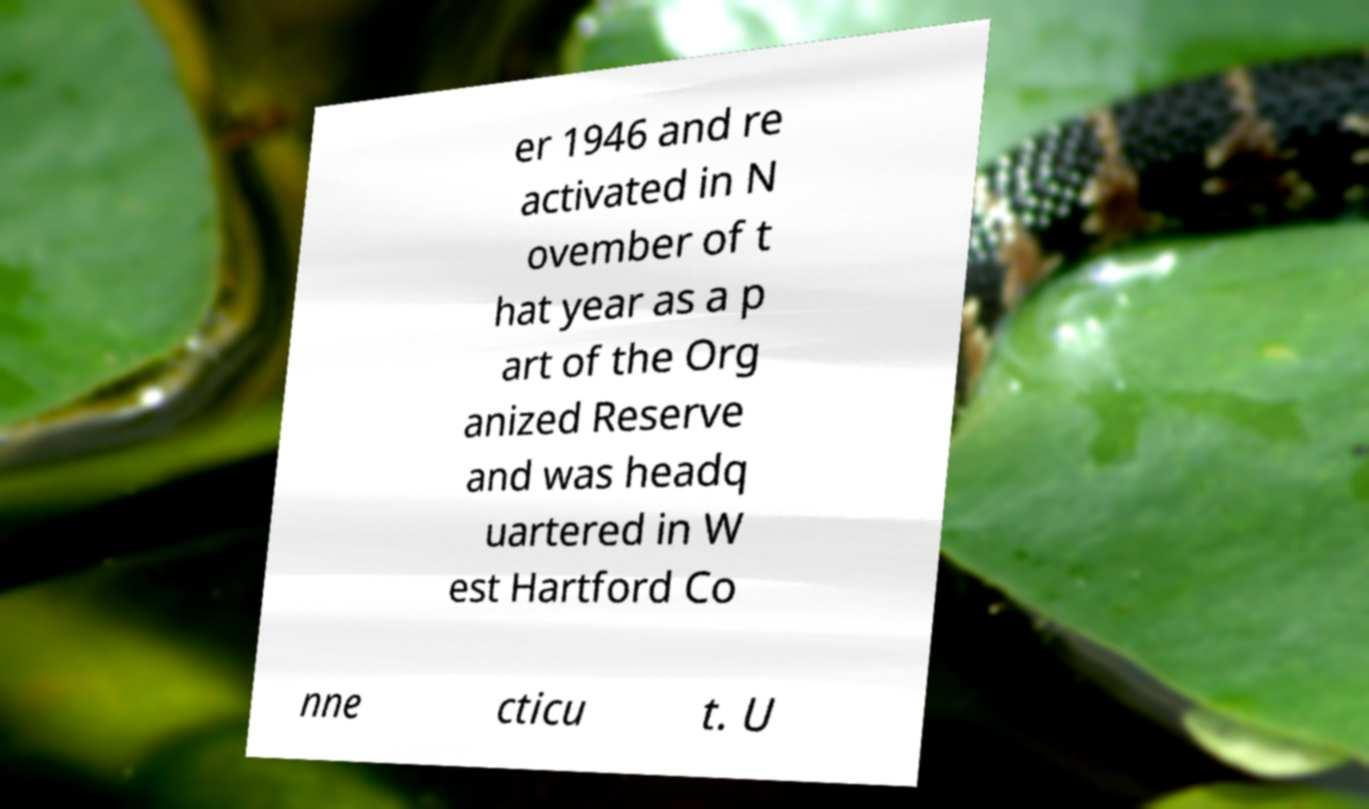I need the written content from this picture converted into text. Can you do that? er 1946 and re activated in N ovember of t hat year as a p art of the Org anized Reserve and was headq uartered in W est Hartford Co nne cticu t. U 